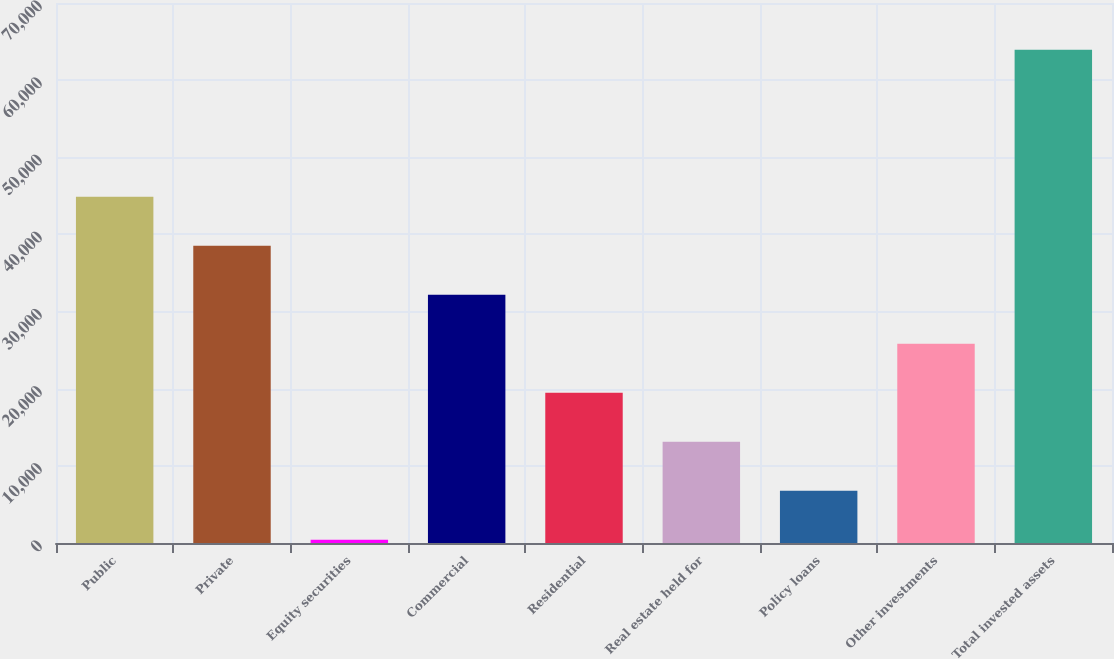<chart> <loc_0><loc_0><loc_500><loc_500><bar_chart><fcel>Public<fcel>Private<fcel>Equity securities<fcel>Commercial<fcel>Residential<fcel>Real estate held for<fcel>Policy loans<fcel>Other investments<fcel>Total invested assets<nl><fcel>44886.2<fcel>38536.1<fcel>435.5<fcel>32186<fcel>19485.8<fcel>13135.7<fcel>6785.6<fcel>25835.9<fcel>63936.5<nl></chart> 